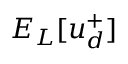<formula> <loc_0><loc_0><loc_500><loc_500>E _ { L } [ u _ { d } ^ { + } ]</formula> 